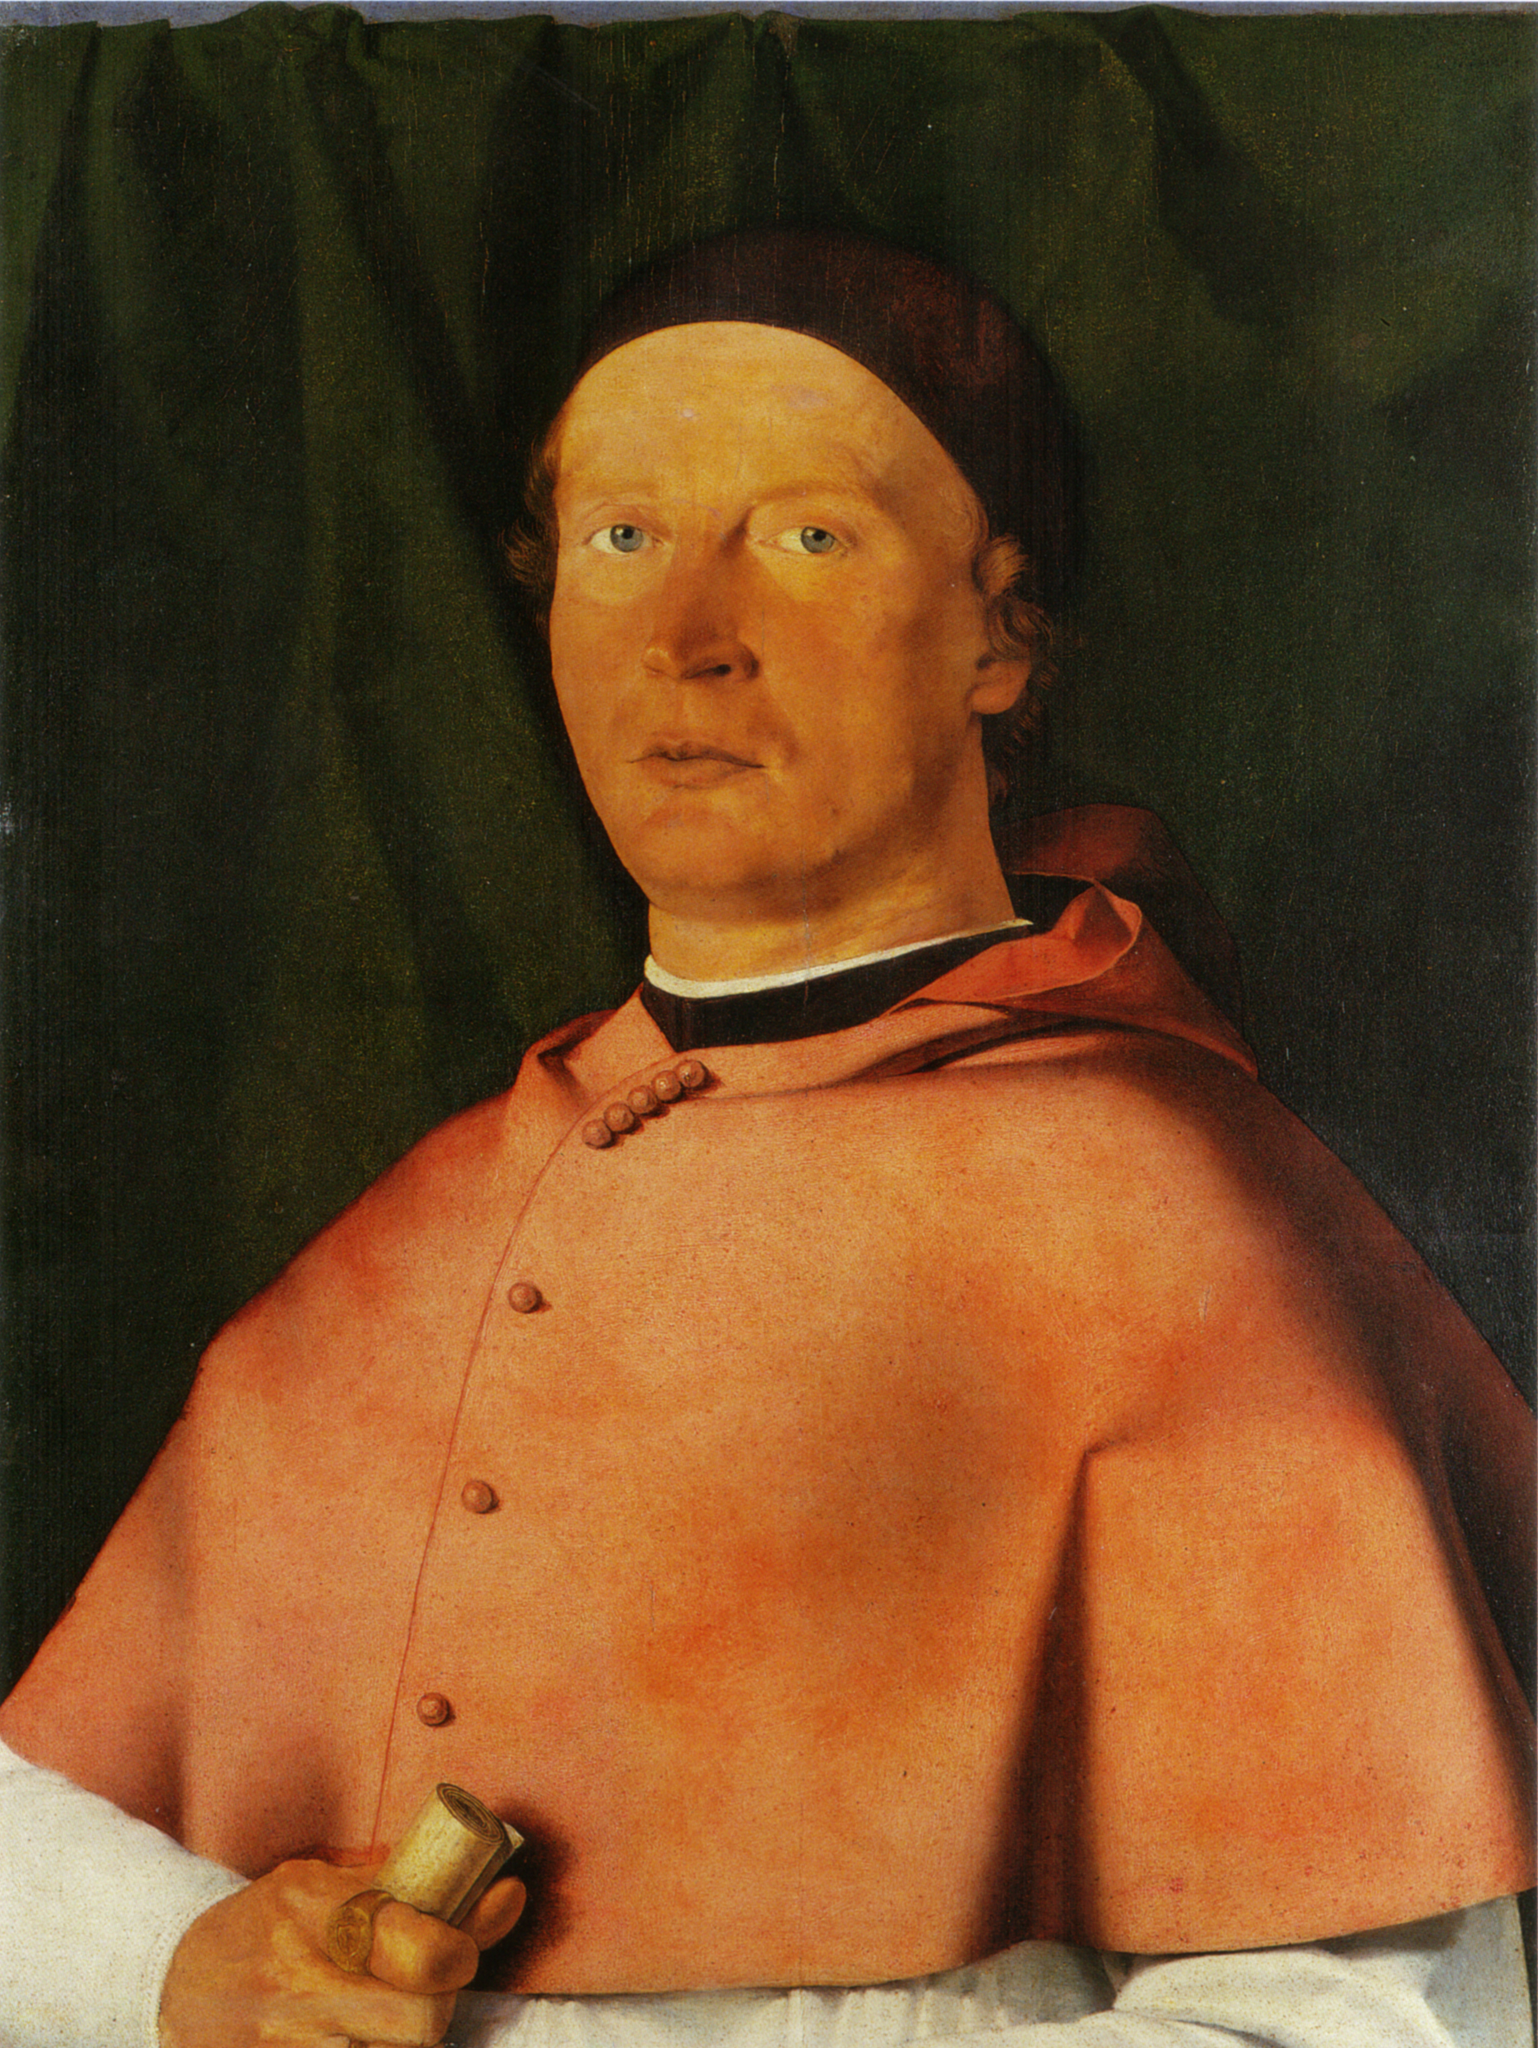How do you think the artist chose the color palette for this painting? The artist appeared to have chosen a restrained yet powerful color palette to emphasize the subject's importance and the solemnity of the portrait. The vivid red of the man’s robe is striking against the muted, dark green background, symbolizing perhaps his significance and authority. The use of black in his cap and the subtle shadows adds to the depth and seriousness of his character. This deliberate choice of colors not only directs attention to the man’s face and attire but also creates a stark contrast that highlights the intricate details and the painter's skillful depiction of light and texture. This limited palette, with its juxtaposition of dark and vibrant hues, fosters a composition that commands attention and exudes a profound sense of gravitas. 